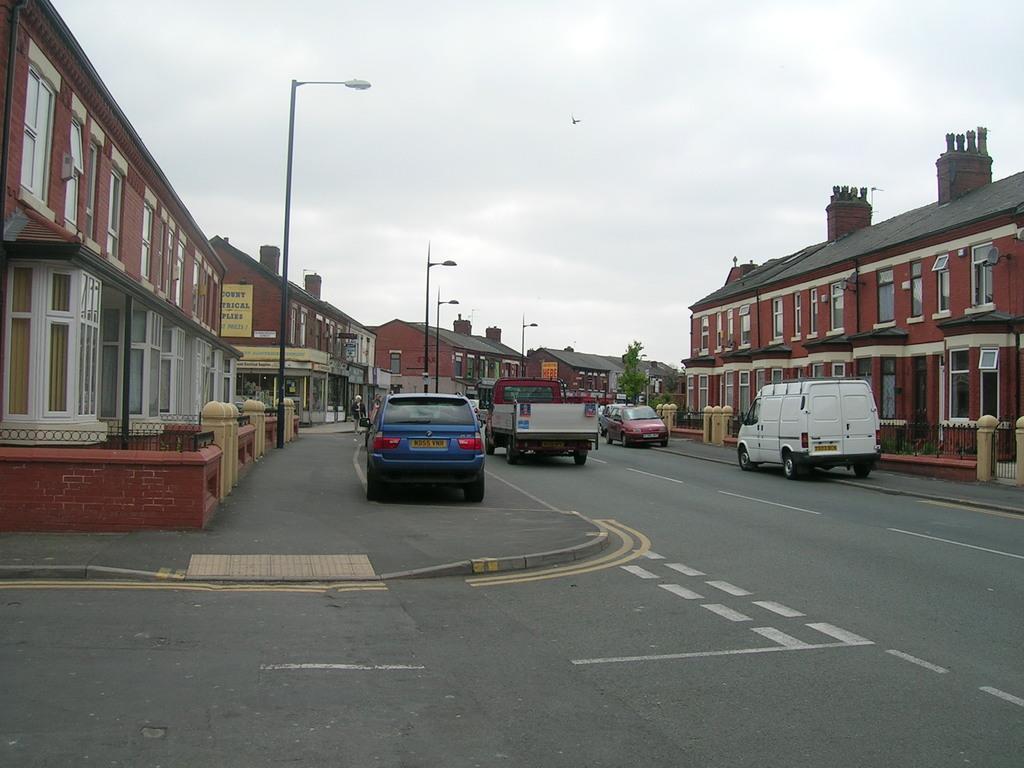How would you summarize this image in a sentence or two? In this image we can see the buildings, railing, fencing wall, light poles, hoardings, tree and also the vehicles passing on the road. We can also see the cloudy sky. 